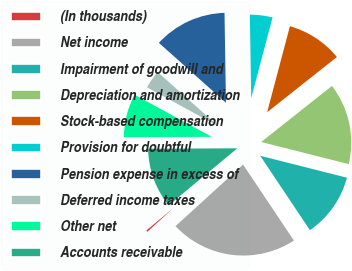<chart> <loc_0><loc_0><loc_500><loc_500><pie_chart><fcel>(In thousands)<fcel>Net income<fcel>Impairment of goodwill and<fcel>Depreciation and amortization<fcel>Stock-based compensation<fcel>Provision for doubtful<fcel>Pension expense in excess of<fcel>Deferred income taxes<fcel>Other net<fcel>Accounts receivable<nl><fcel>0.73%<fcel>22.62%<fcel>11.68%<fcel>14.6%<fcel>10.22%<fcel>4.38%<fcel>13.14%<fcel>3.65%<fcel>8.03%<fcel>10.95%<nl></chart> 